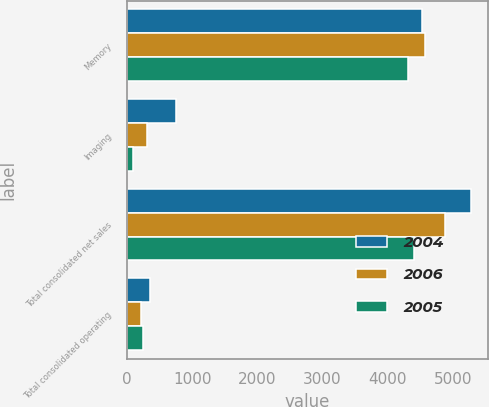<chart> <loc_0><loc_0><loc_500><loc_500><stacked_bar_chart><ecel><fcel>Memory<fcel>Imaging<fcel>Total consolidated net sales<fcel>Total consolidated operating<nl><fcel>2004<fcel>4523<fcel>749<fcel>5272<fcel>350<nl><fcel>2006<fcel>4577<fcel>303<fcel>4880<fcel>217<nl><fcel>2005<fcel>4305<fcel>99<fcel>4404<fcel>250<nl></chart> 